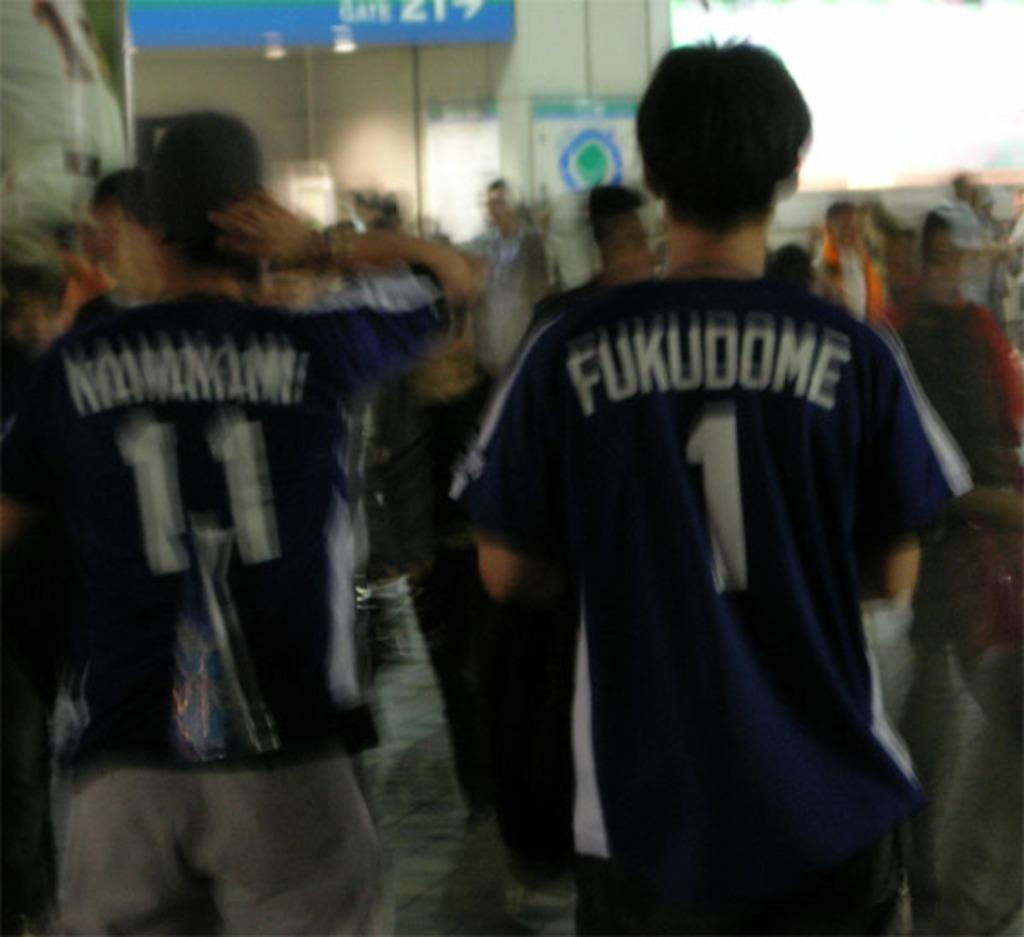<image>
Summarize the visual content of the image. A person wears a number 1 jersey with the word Fukudome on the back. 